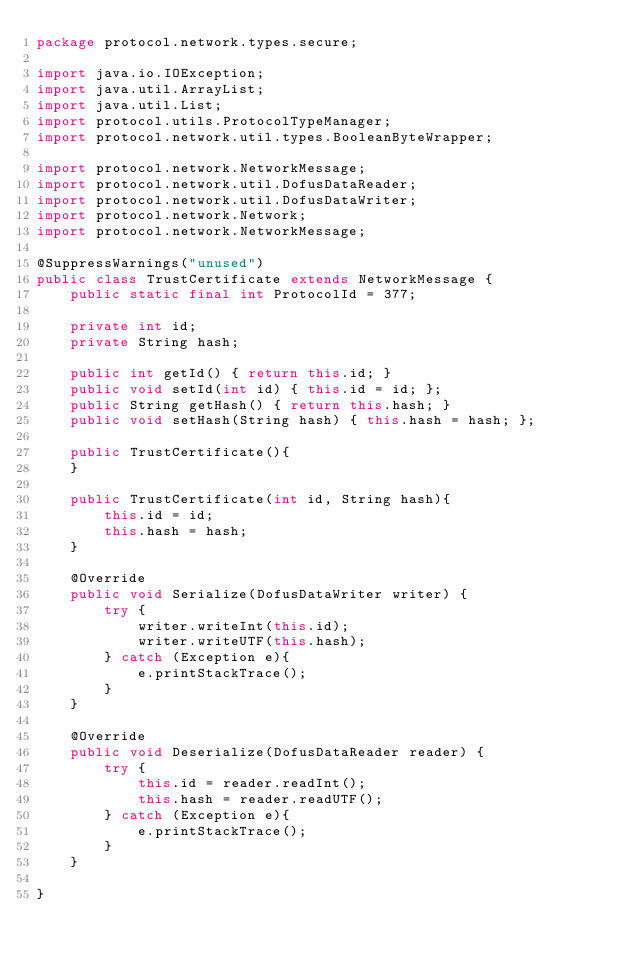<code> <loc_0><loc_0><loc_500><loc_500><_Java_>package protocol.network.types.secure;

import java.io.IOException;
import java.util.ArrayList;
import java.util.List;
import protocol.utils.ProtocolTypeManager;
import protocol.network.util.types.BooleanByteWrapper;

import protocol.network.NetworkMessage;
import protocol.network.util.DofusDataReader;
import protocol.network.util.DofusDataWriter;
import protocol.network.Network;
import protocol.network.NetworkMessage;

@SuppressWarnings("unused")
public class TrustCertificate extends NetworkMessage {
	public static final int ProtocolId = 377;

	private int id;
	private String hash;

	public int getId() { return this.id; }
	public void setId(int id) { this.id = id; };
	public String getHash() { return this.hash; }
	public void setHash(String hash) { this.hash = hash; };

	public TrustCertificate(){
	}

	public TrustCertificate(int id, String hash){
		this.id = id;
		this.hash = hash;
	}

	@Override
	public void Serialize(DofusDataWriter writer) {
		try {
			writer.writeInt(this.id);
			writer.writeUTF(this.hash);
		} catch (Exception e){
			e.printStackTrace();
		}
	}

	@Override
	public void Deserialize(DofusDataReader reader) {
		try {
			this.id = reader.readInt();
			this.hash = reader.readUTF();
		} catch (Exception e){
			e.printStackTrace();
		}
	}

}
</code> 